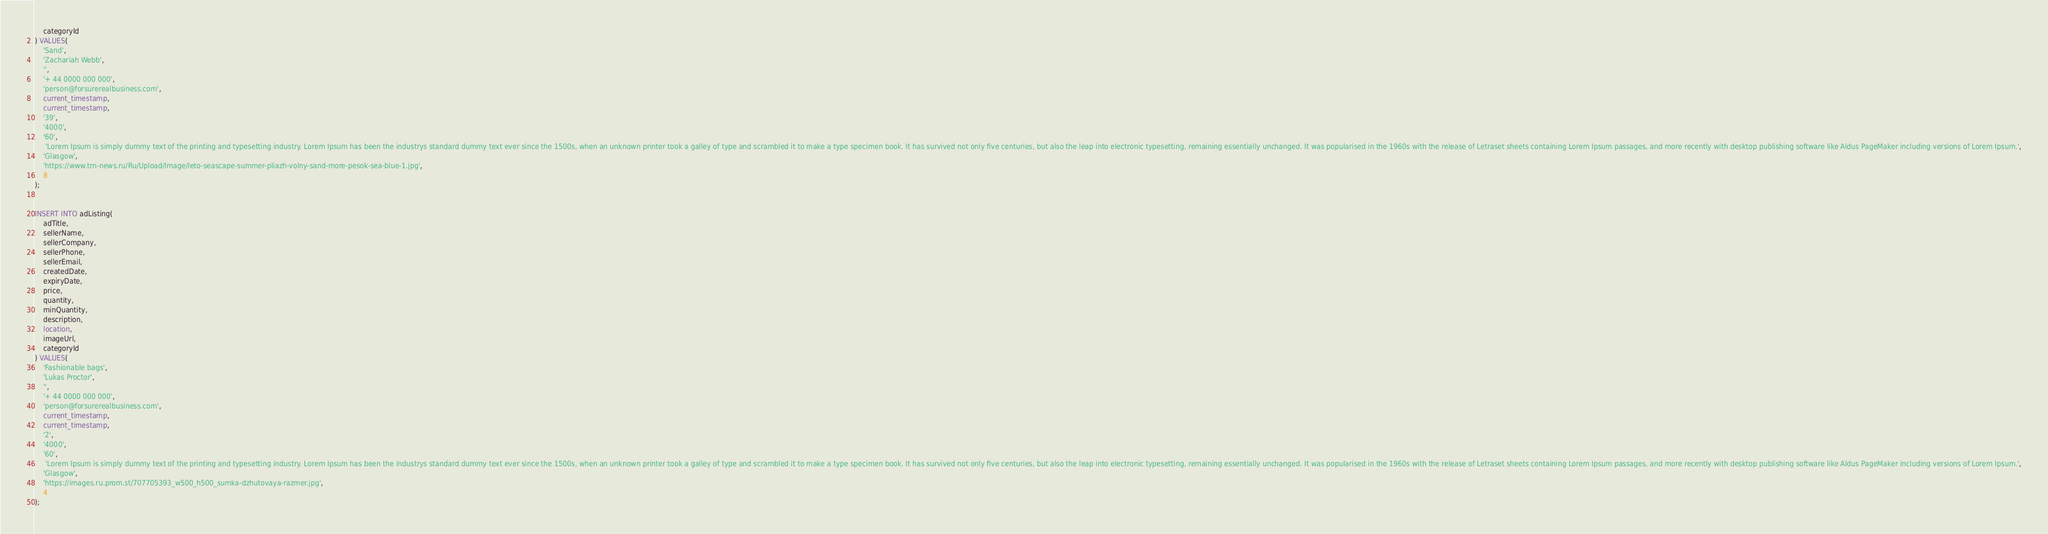Convert code to text. <code><loc_0><loc_0><loc_500><loc_500><_SQL_>    categoryId
) VALUES(
    'Sand', 
    'Zachariah Webb', 
    '', 
    '+ 44 0000 000 000',
    'person@forsurerealbusiness.com',
    current_timestamp,
    current_timestamp,
    '39',
    '4000',
    '60',
     'Lorem Ipsum is simply dummy text of the printing and typesetting industry. Lorem Ipsum has been the industrys standard dummy text ever since the 1500s, when an unknown printer took a galley of type and scrambled it to make a type specimen book. It has survived not only five centuries, but also the leap into electronic typesetting, remaining essentially unchanged. It was popularised in the 1960s with the release of Letraset sheets containing Lorem Ipsum passages, and more recently with desktop publishing software like Aldus PageMaker including versions of Lorem Ipsum.',
    'Glasgow',
    'https://www.trn-news.ru/Ru/Upload/Image/leto-seascape-summer-pliazh-volny-sand-more-pesok-sea-blue-1.jpg',
    8
);


INSERT INTO adListing(
    adTitle, 
    sellerName, 
    sellerCompany, 
    sellerPhone, 
    sellerEmail, 
    createdDate, 
    expiryDate, 
    price, 
    quantity, 
    minQuantity, 
    description, 
    location, 
    imageUrl, 
    categoryId
) VALUES(
    'Fashionable bags', 
    'Lukas Proctor', 
    '', 
    '+ 44 0000 000 000',
    'person@forsurerealbusiness.com',
    current_timestamp,
    current_timestamp,
    '2',
    '4000',
    '60',
     'Lorem Ipsum is simply dummy text of the printing and typesetting industry. Lorem Ipsum has been the industrys standard dummy text ever since the 1500s, when an unknown printer took a galley of type and scrambled it to make a type specimen book. It has survived not only five centuries, but also the leap into electronic typesetting, remaining essentially unchanged. It was popularised in the 1960s with the release of Letraset sheets containing Lorem Ipsum passages, and more recently with desktop publishing software like Aldus PageMaker including versions of Lorem Ipsum.',
    'Glasgow',
    'https://images.ru.prom.st/707705393_w500_h500_sumka-dzhutovaya-razmer.jpg',
    4
);</code> 